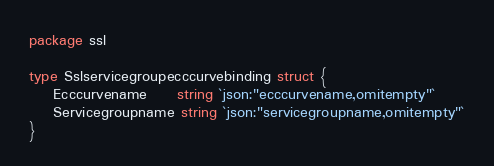Convert code to text. <code><loc_0><loc_0><loc_500><loc_500><_Go_>package ssl

type Sslservicegroupecccurvebinding struct {
	Ecccurvename     string `json:"ecccurvename,omitempty"`
	Servicegroupname string `json:"servicegroupname,omitempty"`
}
</code> 